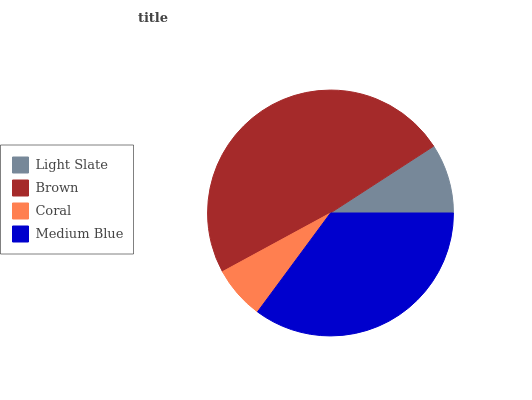Is Coral the minimum?
Answer yes or no. Yes. Is Brown the maximum?
Answer yes or no. Yes. Is Brown the minimum?
Answer yes or no. No. Is Coral the maximum?
Answer yes or no. No. Is Brown greater than Coral?
Answer yes or no. Yes. Is Coral less than Brown?
Answer yes or no. Yes. Is Coral greater than Brown?
Answer yes or no. No. Is Brown less than Coral?
Answer yes or no. No. Is Medium Blue the high median?
Answer yes or no. Yes. Is Light Slate the low median?
Answer yes or no. Yes. Is Light Slate the high median?
Answer yes or no. No. Is Brown the low median?
Answer yes or no. No. 